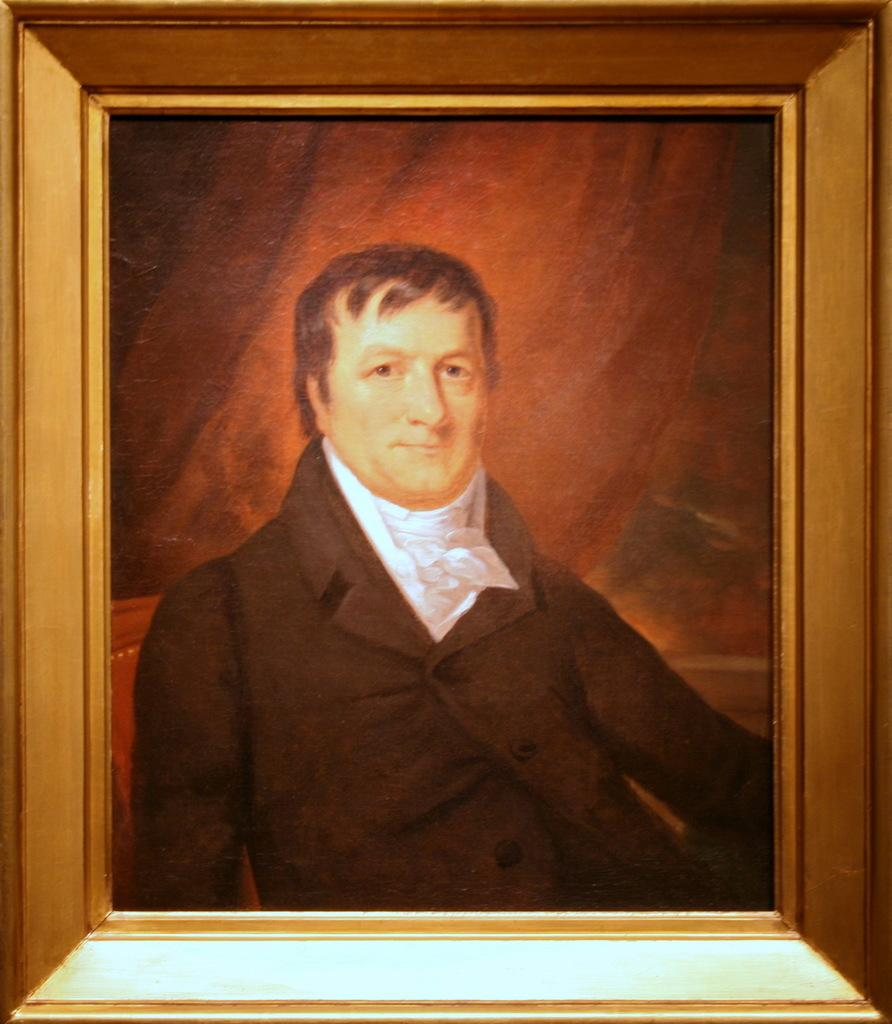What is the main subject of the image? The main subject of the image is a painting of a man. What is the man wearing in the painting? The man is wearing a coat in the painting. How is the painting displayed? The painting is in a photo frame. What type of magic is the man performing in the painting? There is no indication of magic or any magical activity in the painting; the man is simply depicted wearing a coat. 